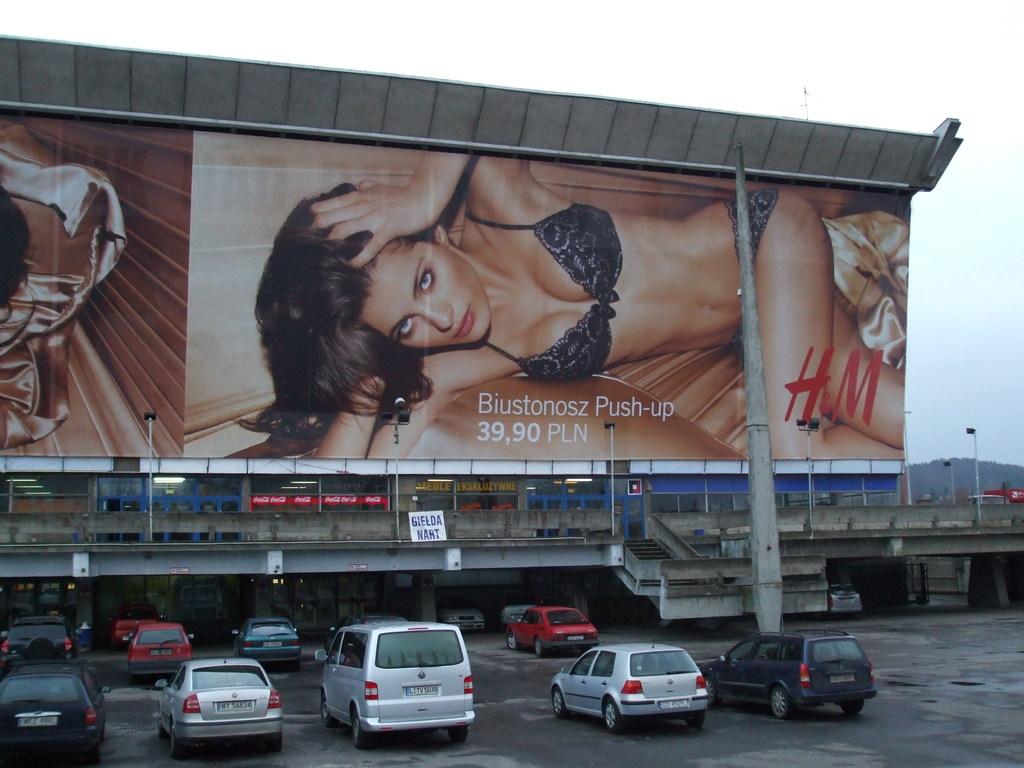What store is selling this item?
Give a very brief answer. H&m. 